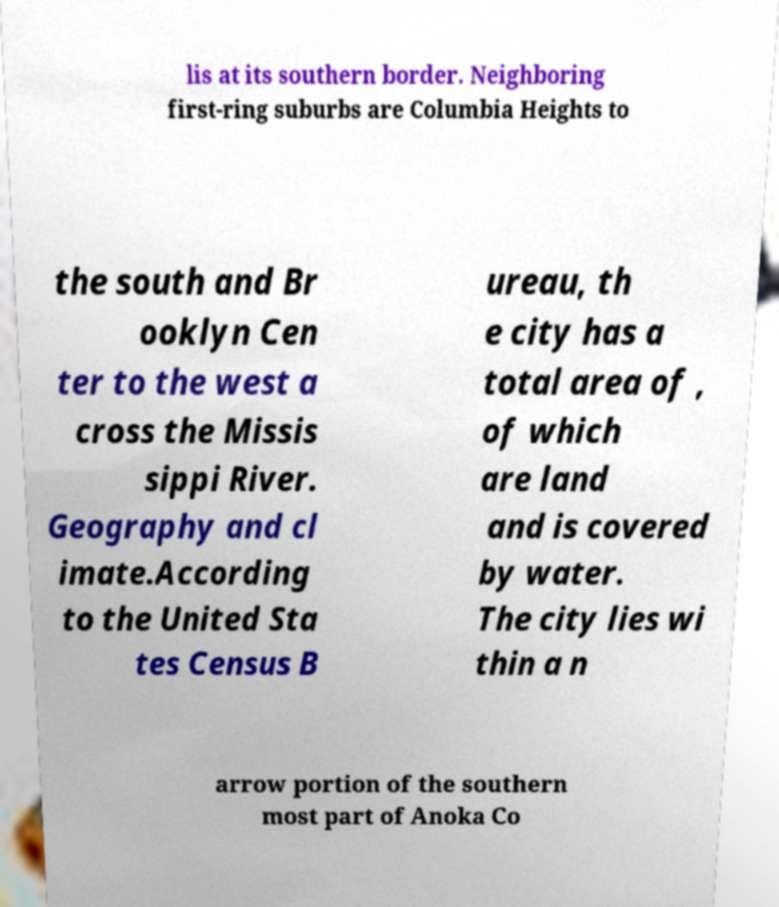There's text embedded in this image that I need extracted. Can you transcribe it verbatim? lis at its southern border. Neighboring first-ring suburbs are Columbia Heights to the south and Br ooklyn Cen ter to the west a cross the Missis sippi River. Geography and cl imate.According to the United Sta tes Census B ureau, th e city has a total area of , of which are land and is covered by water. The city lies wi thin a n arrow portion of the southern most part of Anoka Co 